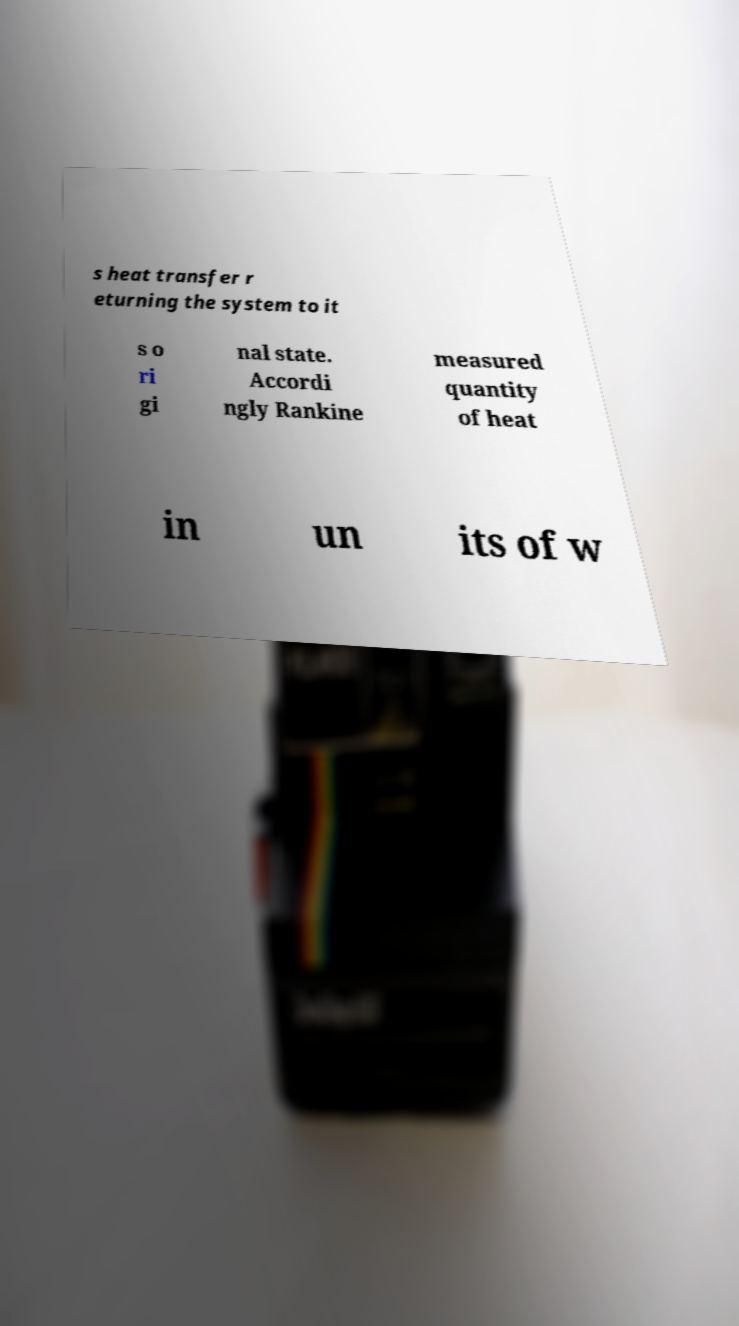Could you extract and type out the text from this image? s heat transfer r eturning the system to it s o ri gi nal state. Accordi ngly Rankine measured quantity of heat in un its of w 